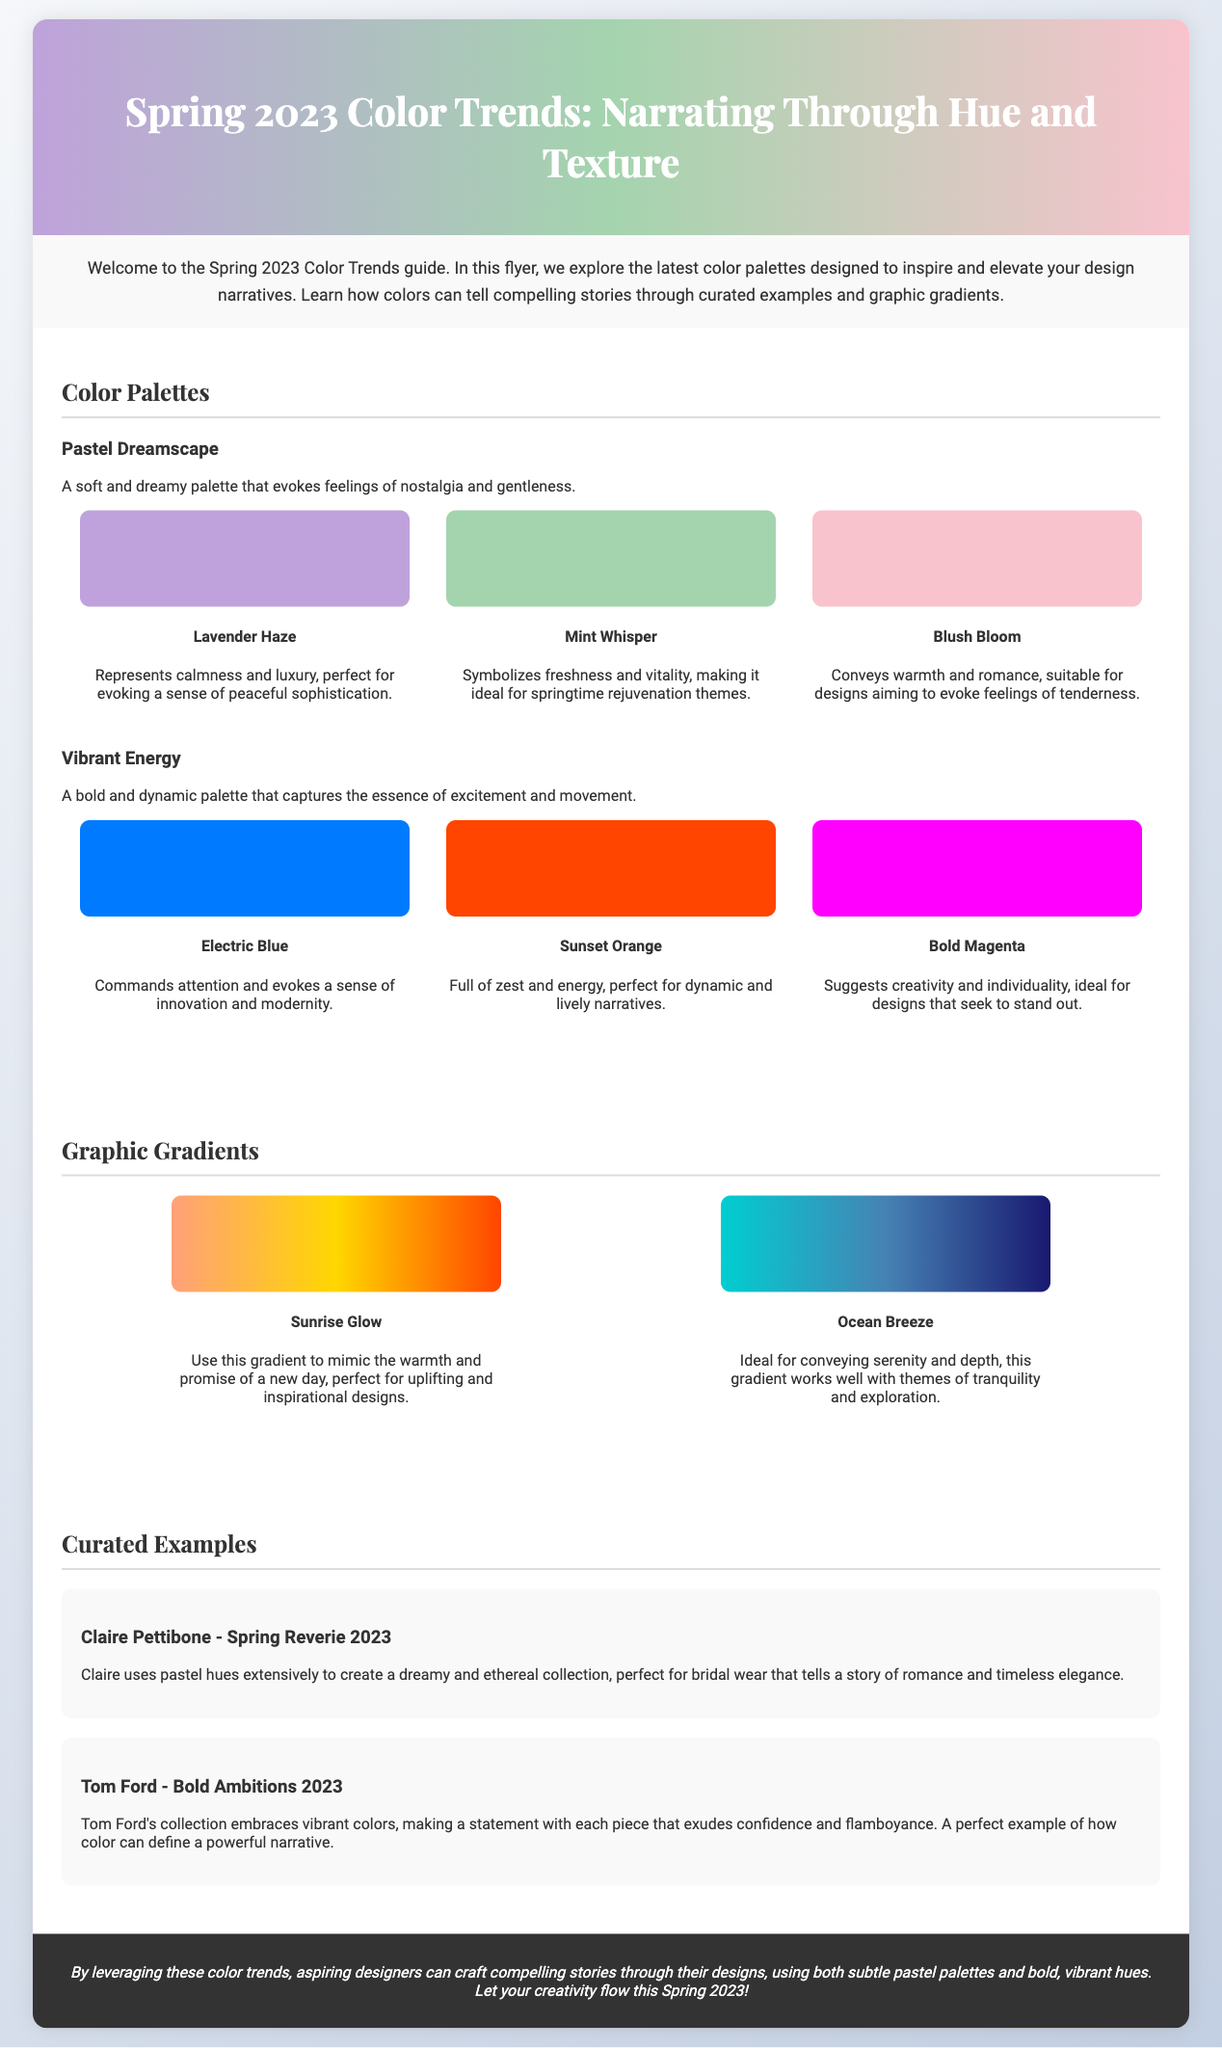what is the title of the flyer? The title of the flyer is presented prominently in the header, which is "Spring 2023 Color Trends: Narrating Through Hue and Texture."
Answer: Spring 2023 Color Trends: Narrating Through Hue and Texture what are the three colors in the Pastel Dreamscape palette? The colors listed in the Pastel Dreamscape palette are Lavender Haze, Mint Whisper, and Blush Bloom.
Answer: Lavender Haze, Mint Whisper, Blush Bloom what emotion does Electric Blue evoke? The document states that Electric Blue "commands attention and evokes a sense of innovation and modernity."
Answer: Innovation and modernity which designer's collection uses pastel hues extensively? The collection by Claire Pettibone is noted for using pastel hues extensively.
Answer: Claire Pettibone what is the purpose of the Sunrise Glow gradient? The purpose of the Sunrise Glow gradient is to mimic "the warmth and promise of a new day."
Answer: Uplifting and inspirational designs what theme does the Mint Whisper color symbolize? The Mint Whisper color symbolizes "freshness and vitality."
Answer: Freshness and vitality how many curated examples are provided? The flyer provides two curated examples of designers and their works.
Answer: Two what type of document is this? The format and content of the document, such as focusing on color trends and inspiration for designers, classify it as a flyer.
Answer: Flyer which color in the Vibrant Energy palette is associated with zest and energy? Sunset Orange is described as "full of zest and energy" in the Vibrant Energy palette.
Answer: Sunset Orange 